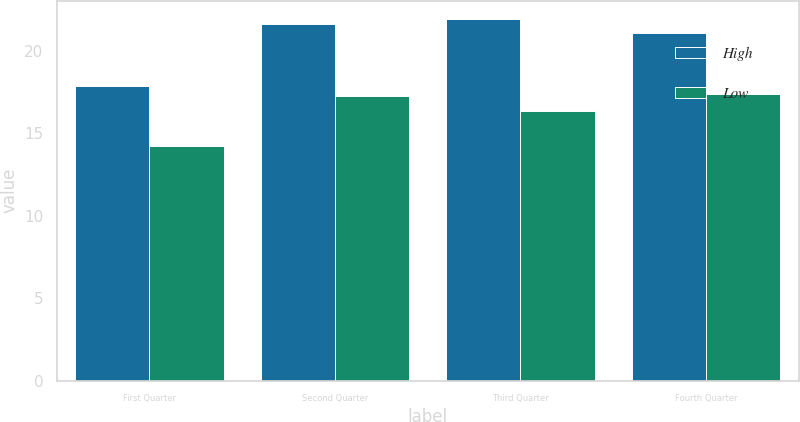Convert chart. <chart><loc_0><loc_0><loc_500><loc_500><stacked_bar_chart><ecel><fcel>First Quarter<fcel>Second Quarter<fcel>Third Quarter<fcel>Fourth Quarter<nl><fcel>High<fcel>17.84<fcel>21.6<fcel>21.93<fcel>21.05<nl><fcel>Low<fcel>14.23<fcel>17.24<fcel>16.32<fcel>17.39<nl></chart> 